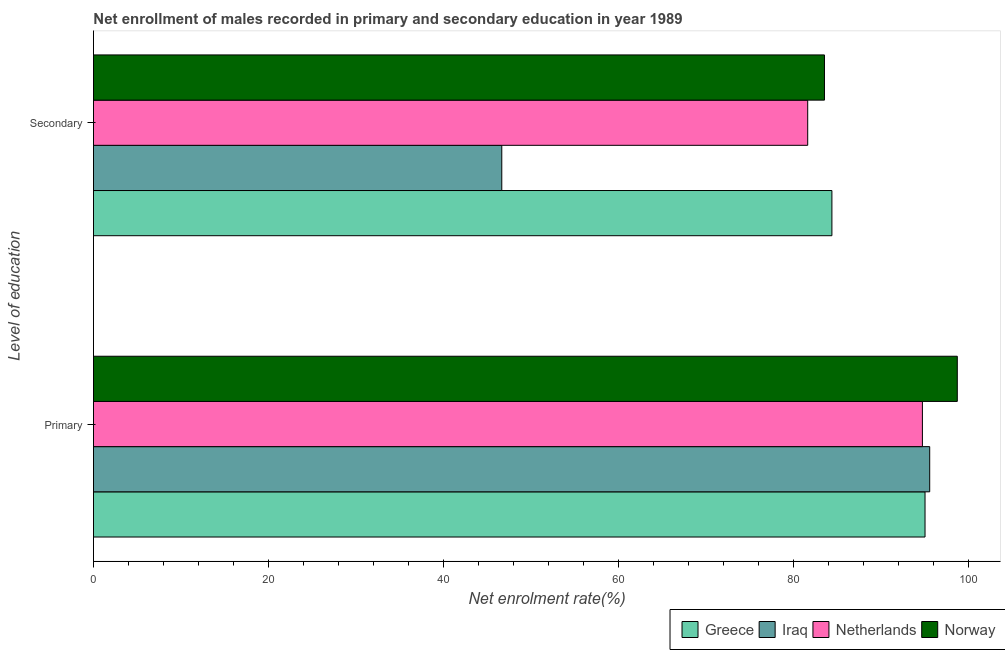How many groups of bars are there?
Offer a terse response. 2. Are the number of bars per tick equal to the number of legend labels?
Provide a succinct answer. Yes. Are the number of bars on each tick of the Y-axis equal?
Offer a terse response. Yes. How many bars are there on the 1st tick from the top?
Your answer should be very brief. 4. How many bars are there on the 1st tick from the bottom?
Keep it short and to the point. 4. What is the label of the 1st group of bars from the top?
Your response must be concise. Secondary. What is the enrollment rate in primary education in Norway?
Provide a short and direct response. 98.75. Across all countries, what is the maximum enrollment rate in secondary education?
Make the answer very short. 84.42. Across all countries, what is the minimum enrollment rate in primary education?
Offer a very short reply. 94.76. In which country was the enrollment rate in primary education maximum?
Offer a terse response. Norway. What is the total enrollment rate in secondary education in the graph?
Ensure brevity in your answer.  296.31. What is the difference between the enrollment rate in secondary education in Netherlands and that in Iraq?
Make the answer very short. 34.97. What is the difference between the enrollment rate in primary education in Norway and the enrollment rate in secondary education in Greece?
Your answer should be compact. 14.33. What is the average enrollment rate in primary education per country?
Provide a succinct answer. 96.04. What is the difference between the enrollment rate in secondary education and enrollment rate in primary education in Iraq?
Your response must be concise. -48.92. In how many countries, is the enrollment rate in primary education greater than 44 %?
Give a very brief answer. 4. What is the ratio of the enrollment rate in primary education in Norway to that in Greece?
Offer a terse response. 1.04. What does the 3rd bar from the top in Primary represents?
Ensure brevity in your answer.  Iraq. What does the 3rd bar from the bottom in Primary represents?
Your response must be concise. Netherlands. How many bars are there?
Provide a short and direct response. 8. Are all the bars in the graph horizontal?
Provide a short and direct response. Yes. What is the difference between two consecutive major ticks on the X-axis?
Make the answer very short. 20. Are the values on the major ticks of X-axis written in scientific E-notation?
Make the answer very short. No. Does the graph contain grids?
Give a very brief answer. No. How are the legend labels stacked?
Your response must be concise. Horizontal. What is the title of the graph?
Provide a short and direct response. Net enrollment of males recorded in primary and secondary education in year 1989. What is the label or title of the X-axis?
Your answer should be very brief. Net enrolment rate(%). What is the label or title of the Y-axis?
Provide a short and direct response. Level of education. What is the Net enrolment rate(%) in Greece in Primary?
Offer a terse response. 95.06. What is the Net enrolment rate(%) of Iraq in Primary?
Give a very brief answer. 95.6. What is the Net enrolment rate(%) in Netherlands in Primary?
Offer a very short reply. 94.76. What is the Net enrolment rate(%) in Norway in Primary?
Make the answer very short. 98.75. What is the Net enrolment rate(%) in Greece in Secondary?
Keep it short and to the point. 84.42. What is the Net enrolment rate(%) of Iraq in Secondary?
Provide a succinct answer. 46.68. What is the Net enrolment rate(%) in Netherlands in Secondary?
Offer a terse response. 81.65. What is the Net enrolment rate(%) in Norway in Secondary?
Give a very brief answer. 83.57. Across all Level of education, what is the maximum Net enrolment rate(%) in Greece?
Make the answer very short. 95.06. Across all Level of education, what is the maximum Net enrolment rate(%) in Iraq?
Your answer should be compact. 95.6. Across all Level of education, what is the maximum Net enrolment rate(%) of Netherlands?
Provide a short and direct response. 94.76. Across all Level of education, what is the maximum Net enrolment rate(%) of Norway?
Your response must be concise. 98.75. Across all Level of education, what is the minimum Net enrolment rate(%) in Greece?
Offer a very short reply. 84.42. Across all Level of education, what is the minimum Net enrolment rate(%) of Iraq?
Your answer should be compact. 46.68. Across all Level of education, what is the minimum Net enrolment rate(%) of Netherlands?
Offer a terse response. 81.65. Across all Level of education, what is the minimum Net enrolment rate(%) of Norway?
Ensure brevity in your answer.  83.57. What is the total Net enrolment rate(%) of Greece in the graph?
Your response must be concise. 179.48. What is the total Net enrolment rate(%) in Iraq in the graph?
Ensure brevity in your answer.  142.27. What is the total Net enrolment rate(%) of Netherlands in the graph?
Your answer should be very brief. 176.41. What is the total Net enrolment rate(%) in Norway in the graph?
Offer a terse response. 182.32. What is the difference between the Net enrolment rate(%) in Greece in Primary and that in Secondary?
Keep it short and to the point. 10.64. What is the difference between the Net enrolment rate(%) of Iraq in Primary and that in Secondary?
Give a very brief answer. 48.92. What is the difference between the Net enrolment rate(%) of Netherlands in Primary and that in Secondary?
Make the answer very short. 13.11. What is the difference between the Net enrolment rate(%) of Norway in Primary and that in Secondary?
Provide a short and direct response. 15.19. What is the difference between the Net enrolment rate(%) in Greece in Primary and the Net enrolment rate(%) in Iraq in Secondary?
Give a very brief answer. 48.38. What is the difference between the Net enrolment rate(%) of Greece in Primary and the Net enrolment rate(%) of Netherlands in Secondary?
Keep it short and to the point. 13.41. What is the difference between the Net enrolment rate(%) of Greece in Primary and the Net enrolment rate(%) of Norway in Secondary?
Give a very brief answer. 11.5. What is the difference between the Net enrolment rate(%) in Iraq in Primary and the Net enrolment rate(%) in Netherlands in Secondary?
Your response must be concise. 13.95. What is the difference between the Net enrolment rate(%) in Iraq in Primary and the Net enrolment rate(%) in Norway in Secondary?
Your answer should be very brief. 12.03. What is the difference between the Net enrolment rate(%) of Netherlands in Primary and the Net enrolment rate(%) of Norway in Secondary?
Offer a terse response. 11.2. What is the average Net enrolment rate(%) in Greece per Level of education?
Provide a short and direct response. 89.74. What is the average Net enrolment rate(%) of Iraq per Level of education?
Keep it short and to the point. 71.14. What is the average Net enrolment rate(%) of Netherlands per Level of education?
Offer a very short reply. 88.2. What is the average Net enrolment rate(%) in Norway per Level of education?
Provide a short and direct response. 91.16. What is the difference between the Net enrolment rate(%) in Greece and Net enrolment rate(%) in Iraq in Primary?
Give a very brief answer. -0.53. What is the difference between the Net enrolment rate(%) of Greece and Net enrolment rate(%) of Netherlands in Primary?
Provide a short and direct response. 0.3. What is the difference between the Net enrolment rate(%) of Greece and Net enrolment rate(%) of Norway in Primary?
Ensure brevity in your answer.  -3.69. What is the difference between the Net enrolment rate(%) in Iraq and Net enrolment rate(%) in Netherlands in Primary?
Your answer should be very brief. 0.83. What is the difference between the Net enrolment rate(%) in Iraq and Net enrolment rate(%) in Norway in Primary?
Make the answer very short. -3.15. What is the difference between the Net enrolment rate(%) in Netherlands and Net enrolment rate(%) in Norway in Primary?
Your answer should be very brief. -3.99. What is the difference between the Net enrolment rate(%) in Greece and Net enrolment rate(%) in Iraq in Secondary?
Offer a terse response. 37.74. What is the difference between the Net enrolment rate(%) of Greece and Net enrolment rate(%) of Netherlands in Secondary?
Give a very brief answer. 2.77. What is the difference between the Net enrolment rate(%) of Greece and Net enrolment rate(%) of Norway in Secondary?
Ensure brevity in your answer.  0.85. What is the difference between the Net enrolment rate(%) of Iraq and Net enrolment rate(%) of Netherlands in Secondary?
Offer a terse response. -34.97. What is the difference between the Net enrolment rate(%) of Iraq and Net enrolment rate(%) of Norway in Secondary?
Ensure brevity in your answer.  -36.89. What is the difference between the Net enrolment rate(%) in Netherlands and Net enrolment rate(%) in Norway in Secondary?
Your response must be concise. -1.92. What is the ratio of the Net enrolment rate(%) of Greece in Primary to that in Secondary?
Make the answer very short. 1.13. What is the ratio of the Net enrolment rate(%) of Iraq in Primary to that in Secondary?
Your answer should be very brief. 2.05. What is the ratio of the Net enrolment rate(%) of Netherlands in Primary to that in Secondary?
Your answer should be very brief. 1.16. What is the ratio of the Net enrolment rate(%) of Norway in Primary to that in Secondary?
Give a very brief answer. 1.18. What is the difference between the highest and the second highest Net enrolment rate(%) of Greece?
Offer a very short reply. 10.64. What is the difference between the highest and the second highest Net enrolment rate(%) in Iraq?
Offer a terse response. 48.92. What is the difference between the highest and the second highest Net enrolment rate(%) of Netherlands?
Give a very brief answer. 13.11. What is the difference between the highest and the second highest Net enrolment rate(%) in Norway?
Your answer should be compact. 15.19. What is the difference between the highest and the lowest Net enrolment rate(%) of Greece?
Provide a succinct answer. 10.64. What is the difference between the highest and the lowest Net enrolment rate(%) in Iraq?
Offer a very short reply. 48.92. What is the difference between the highest and the lowest Net enrolment rate(%) in Netherlands?
Your response must be concise. 13.11. What is the difference between the highest and the lowest Net enrolment rate(%) in Norway?
Ensure brevity in your answer.  15.19. 